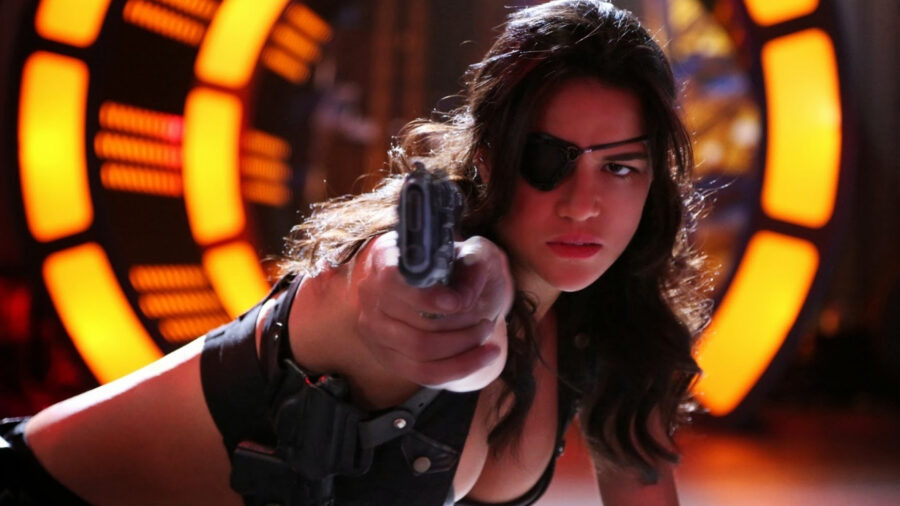What kind of technology might be present in the scene? The image hints at a futuristic setting characterized by the prominent glowing lights in the background, which might be part of advanced technological interfaces or infrastructure. These lights contribute to an atmosphere that could involve high-tech elements, such as holographic displays, advanced weaponry, or futuristic architecture, suggesting a setting far beyond current technological capabilities. The woman’s attire and equipment might also include sophisticated gadgets or combat gear suited for a high-tech environment. If this scene were part of a larger story, what genre would it most likely belong to? Judging by the intense action, the character’s appearance, and the futuristic elements of the scene, this image would most likely be part of a science fiction or action genre. It could feature in a story where advanced technology, combat, and possibly dystopian themes are prevalent. The character's determined expression and readiness for battle suggest it could be a high-stakes narrative involving significant challenges and intense confrontations.  Imagine this woman is a intergalactic bounty hunter in a distant future, describe an exciting scene she might be experiencing. In a distant future, the woman, an intergalactic bounty hunter known for her unparalleled skills and relentless pursuit of justice, navigates the bustling neon-lit streets of a technologically advanced colony on a distant planet. As she stalks her latest target, a notorious smuggler with high-tech invisibility gear, her enhanced vision scanners pick up faint traces of his heat signature. The chase ensues through narrow alleyways, filled with towering holographic advertisements and floating market stalls. She seamlessly hurdles over obstacles, her cybernetic enhancements giving her an edge as she closes in on her prey. Suddenly, the smuggler turns to fire his plasma pistol, but she dodges expertly, returning fire with her own energy weapon that hums with power. The exchange of blasts illuminates the dark alleys in flashes of blue and red. Ultimately, using her cunning and combat prowess, she subdues him, securing yet another successful capture. Her reputation as the most feared and respected bounty hunter in the galaxy remains untarnished. 